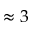<formula> <loc_0><loc_0><loc_500><loc_500>\approx 3</formula> 